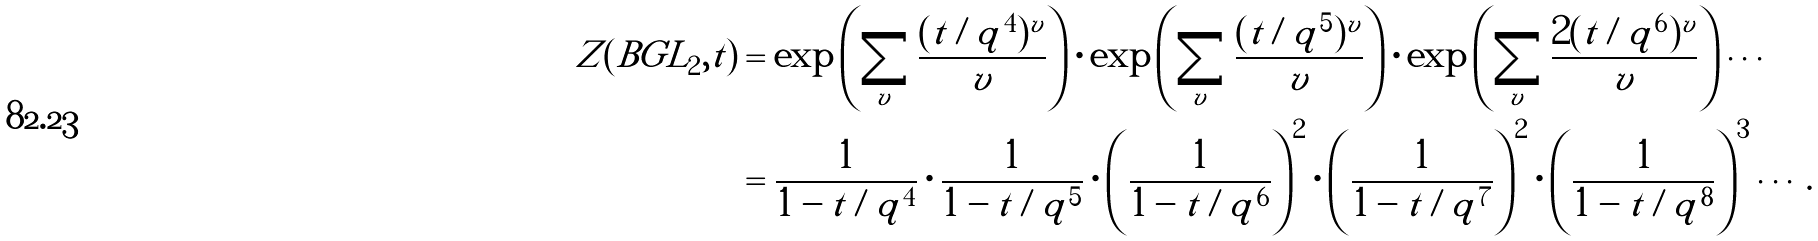<formula> <loc_0><loc_0><loc_500><loc_500>Z ( B G L _ { 2 } , t ) & = \exp \left ( \sum _ { v } \frac { ( t / q ^ { 4 } ) ^ { v } } { v } \right ) \cdot \exp \left ( \sum _ { v } \frac { ( t / q ^ { 5 } ) ^ { v } } { v } \right ) \cdot \exp \left ( \sum _ { v } \frac { 2 ( t / q ^ { 6 } ) ^ { v } } { v } \right ) \cdots \\ & = \frac { 1 } { 1 - t / q ^ { 4 } } \cdot \frac { 1 } { 1 - t / q ^ { 5 } } \cdot \left ( \frac { 1 } { 1 - t / q ^ { 6 } } \right ) ^ { 2 } \cdot \left ( \frac { 1 } { 1 - t / q ^ { 7 } } \right ) ^ { 2 } \cdot \left ( \frac { 1 } { 1 - t / q ^ { 8 } } \right ) ^ { 3 } \cdots .</formula> 